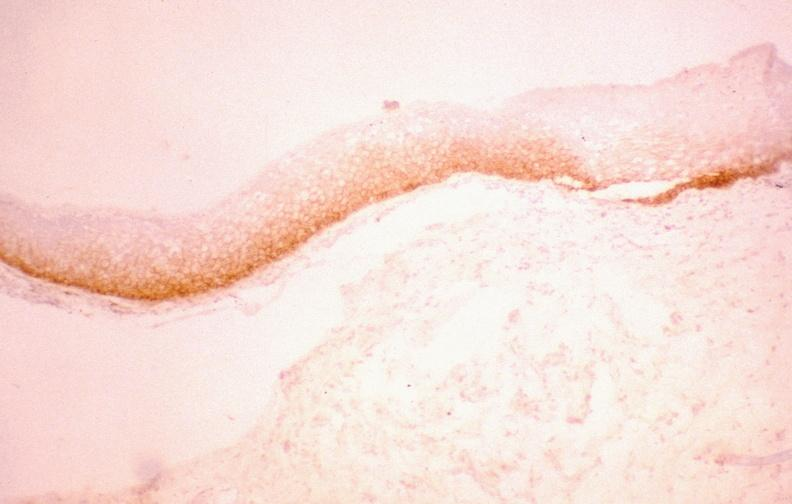does angiogram saphenous vein bypass graft show oral dysplasia, egf receptor?
Answer the question using a single word or phrase. No 